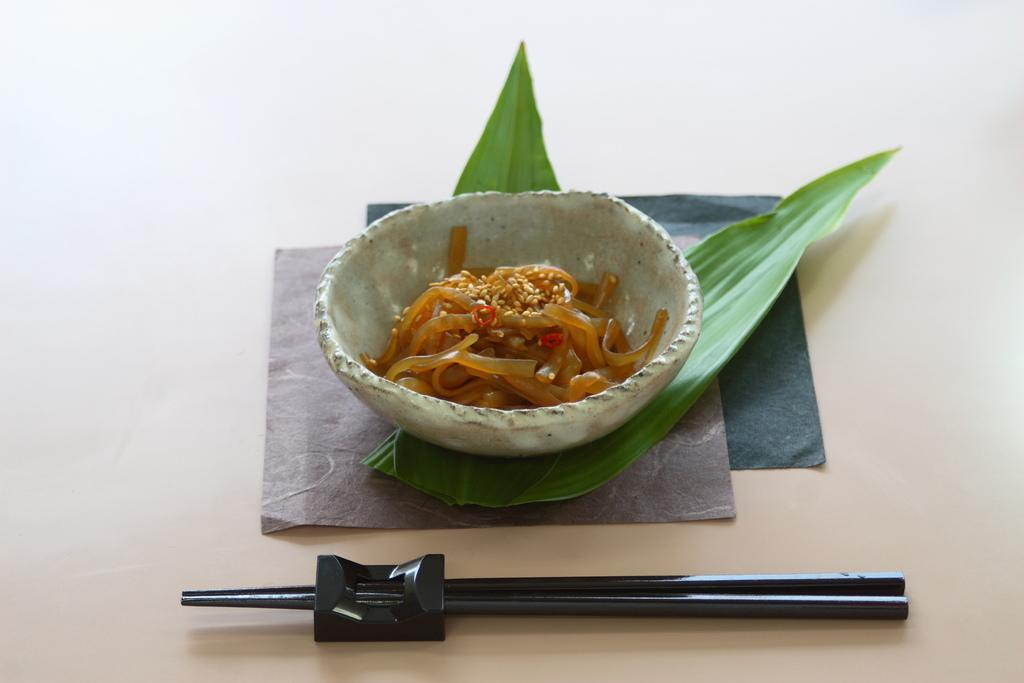What is in the bowl that is visible in the image? There is a bowl containing noodles in the image. Where is the bowl placed? The bowl is placed on leaves. What utensil is present in the image? There is a pair of chopsticks in front of the bowl. What key is used to unlock the bowl in the image? There is no key present in the image, and the bowl is not locked. 